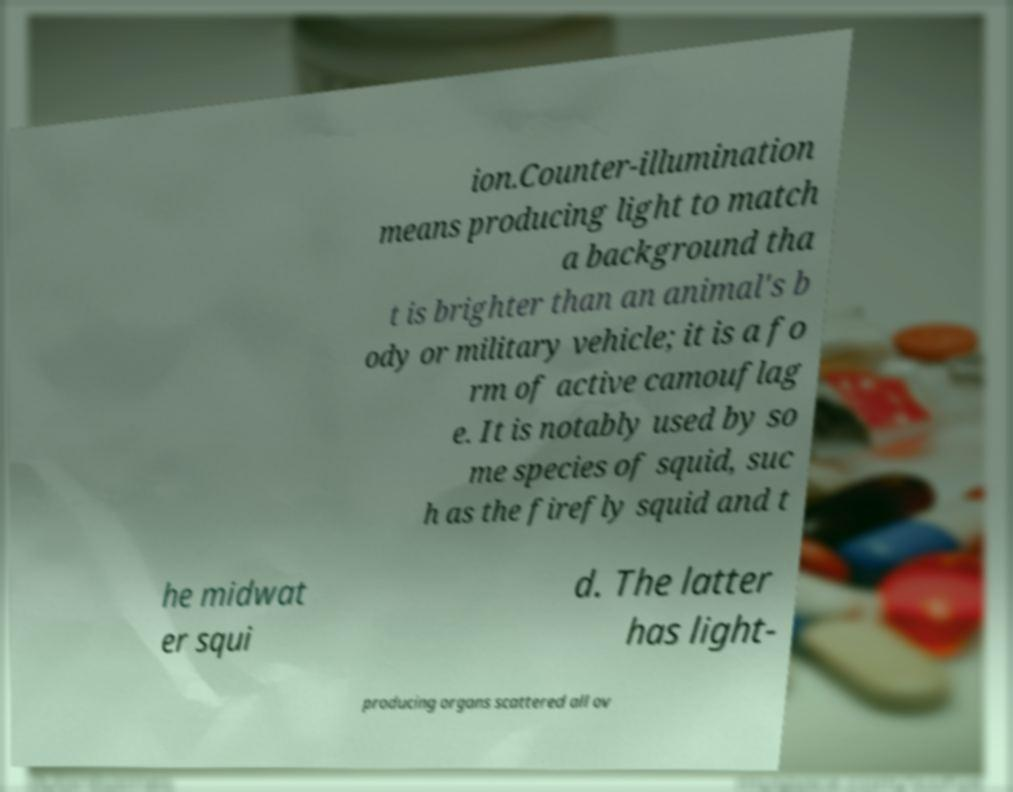Could you assist in decoding the text presented in this image and type it out clearly? ion.Counter-illumination means producing light to match a background tha t is brighter than an animal's b ody or military vehicle; it is a fo rm of active camouflag e. It is notably used by so me species of squid, suc h as the firefly squid and t he midwat er squi d. The latter has light- producing organs scattered all ov 